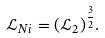<formula> <loc_0><loc_0><loc_500><loc_500>\mathcal { L } _ { N i } = ( \mathcal { L } _ { 2 } ) ^ { \frac { 3 } { 2 } } .</formula> 